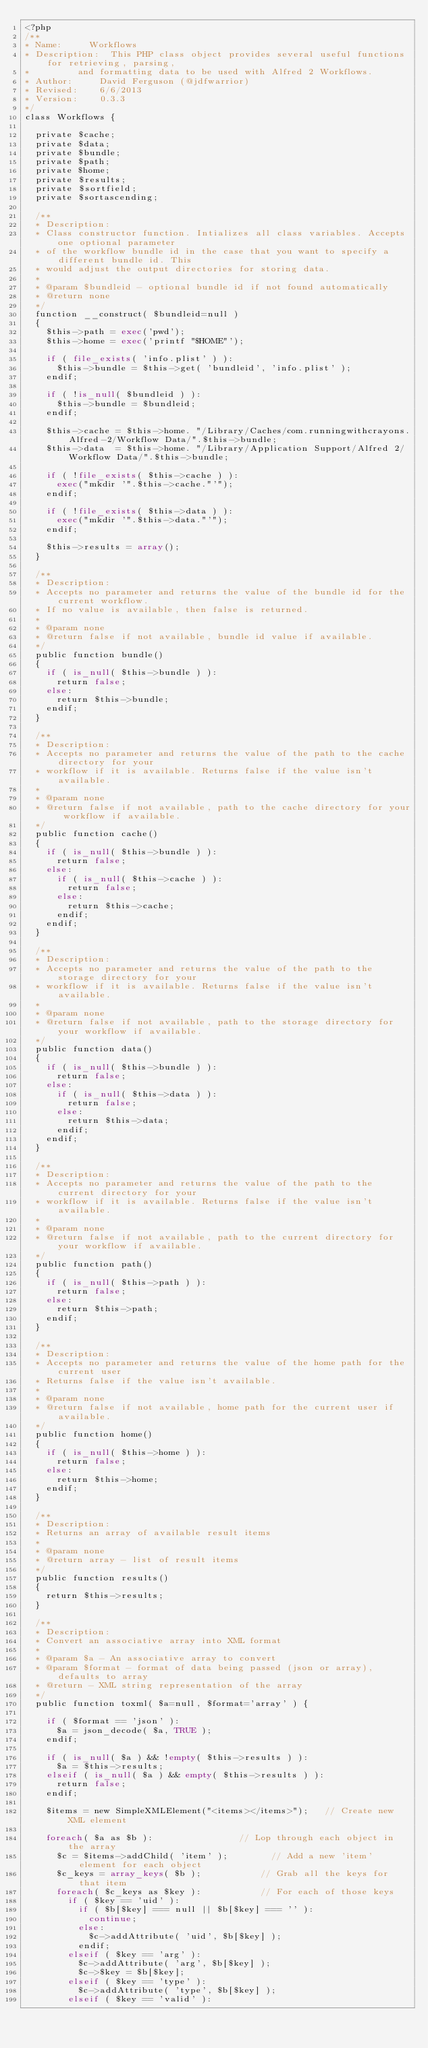<code> <loc_0><loc_0><loc_500><loc_500><_PHP_><?php
/**
* Name: 		Workflows
* Description: 	This PHP class object provides several useful functions for retrieving, parsing,
* 				and formatting data to be used with Alfred 2 Workflows.
* Author: 		David Ferguson (@jdfwarrior)
* Revised: 		6/6/2013
* Version:		0.3.3
*/
class Workflows {

	private $cache;
	private $data;
	private $bundle;
	private $path;
	private $home;
	private $results;
	private $sortfield;
	private $sortascending;

	/**
	* Description:
	* Class constructor function. Intializes all class variables. Accepts one optional parameter
	* of the workflow bundle id in the case that you want to specify a different bundle id. This
	* would adjust the output directories for storing data.
	*
	* @param $bundleid - optional bundle id if not found automatically
	* @return none
	*/
	function __construct( $bundleid=null )
	{
		$this->path = exec('pwd');
		$this->home = exec('printf "$HOME"');

		if ( file_exists( 'info.plist' ) ):
			$this->bundle = $this->get( 'bundleid', 'info.plist' );
		endif;

		if ( !is_null( $bundleid ) ):
			$this->bundle = $bundleid;
		endif;

		$this->cache = $this->home. "/Library/Caches/com.runningwithcrayons.Alfred-2/Workflow Data/".$this->bundle;
		$this->data  = $this->home. "/Library/Application Support/Alfred 2/Workflow Data/".$this->bundle;

		if ( !file_exists( $this->cache ) ):
			exec("mkdir '".$this->cache."'");
		endif;

		if ( !file_exists( $this->data ) ):
			exec("mkdir '".$this->data."'");
		endif;

		$this->results = array();
	}

	/**
	* Description:
	* Accepts no parameter and returns the value of the bundle id for the current workflow.
	* If no value is available, then false is returned.
	*
	* @param none
	* @return false if not available, bundle id value if available.
	*/
	public function bundle()
	{
		if ( is_null( $this->bundle ) ):
			return false;
		else:
			return $this->bundle;
		endif;
	}

	/**
	* Description:
	* Accepts no parameter and returns the value of the path to the cache directory for your
	* workflow if it is available. Returns false if the value isn't available.
	*
	* @param none
	* @return false if not available, path to the cache directory for your workflow if available.
	*/
	public function cache()
	{
		if ( is_null( $this->bundle ) ):
			return false;
		else:
			if ( is_null( $this->cache ) ):
				return false;
			else:
				return $this->cache;
			endif;
		endif;
	}

	/**
	* Description:
	* Accepts no parameter and returns the value of the path to the storage directory for your
	* workflow if it is available. Returns false if the value isn't available.
	*
	* @param none
	* @return false if not available, path to the storage directory for your workflow if available.
	*/
	public function data()
	{
		if ( is_null( $this->bundle ) ):
			return false;
		else:
			if ( is_null( $this->data ) ):
				return false;
			else:
				return $this->data;
			endif;
		endif;
	}

	/**
	* Description:
	* Accepts no parameter and returns the value of the path to the current directory for your
	* workflow if it is available. Returns false if the value isn't available.
	*
	* @param none
	* @return false if not available, path to the current directory for your workflow if available.
	*/
	public function path()
	{
		if ( is_null( $this->path ) ):
			return false;
		else:
			return $this->path;
		endif;
	}

	/**
	* Description:
	* Accepts no parameter and returns the value of the home path for the current user
	* Returns false if the value isn't available.
	*
	* @param none
	* @return false if not available, home path for the current user if available.
	*/
	public function home()
	{
		if ( is_null( $this->home ) ):
			return false;
		else:
			return $this->home;
		endif;
	}

	/**
	* Description:
	* Returns an array of available result items
	*
	* @param none
	* @return array - list of result items
	*/
	public function results()
	{
		return $this->results;
	}

	/**
	* Description:
	* Convert an associative array into XML format
	*
	* @param $a - An associative array to convert
	* @param $format - format of data being passed (json or array), defaults to array
	* @return - XML string representation of the array
	*/
	public function toxml( $a=null, $format='array' ) {

		if ( $format == 'json' ):
			$a = json_decode( $a, TRUE );
		endif;

		if ( is_null( $a ) && !empty( $this->results ) ):
			$a = $this->results;
		elseif ( is_null( $a ) && empty( $this->results ) ):
			return false;
		endif;

		$items = new SimpleXMLElement("<items></items>"); 	// Create new XML element

		foreach( $a as $b ):								// Lop through each object in the array
			$c = $items->addChild( 'item' );				// Add a new 'item' element for each object
			$c_keys = array_keys( $b );						// Grab all the keys for that item
			foreach( $c_keys as $key ):						// For each of those keys
				if ( $key == 'uid' ):
					if ( $b[$key] === null || $b[$key] === '' ):
						continue;
					else:
						$c->addAttribute( 'uid', $b[$key] );
					endif;
				elseif ( $key == 'arg' ):
					$c->addAttribute( 'arg', $b[$key] );
					$c->$key = $b[$key];
				elseif ( $key == 'type' ):
					$c->addAttribute( 'type', $b[$key] );
				elseif ( $key == 'valid' ):</code> 